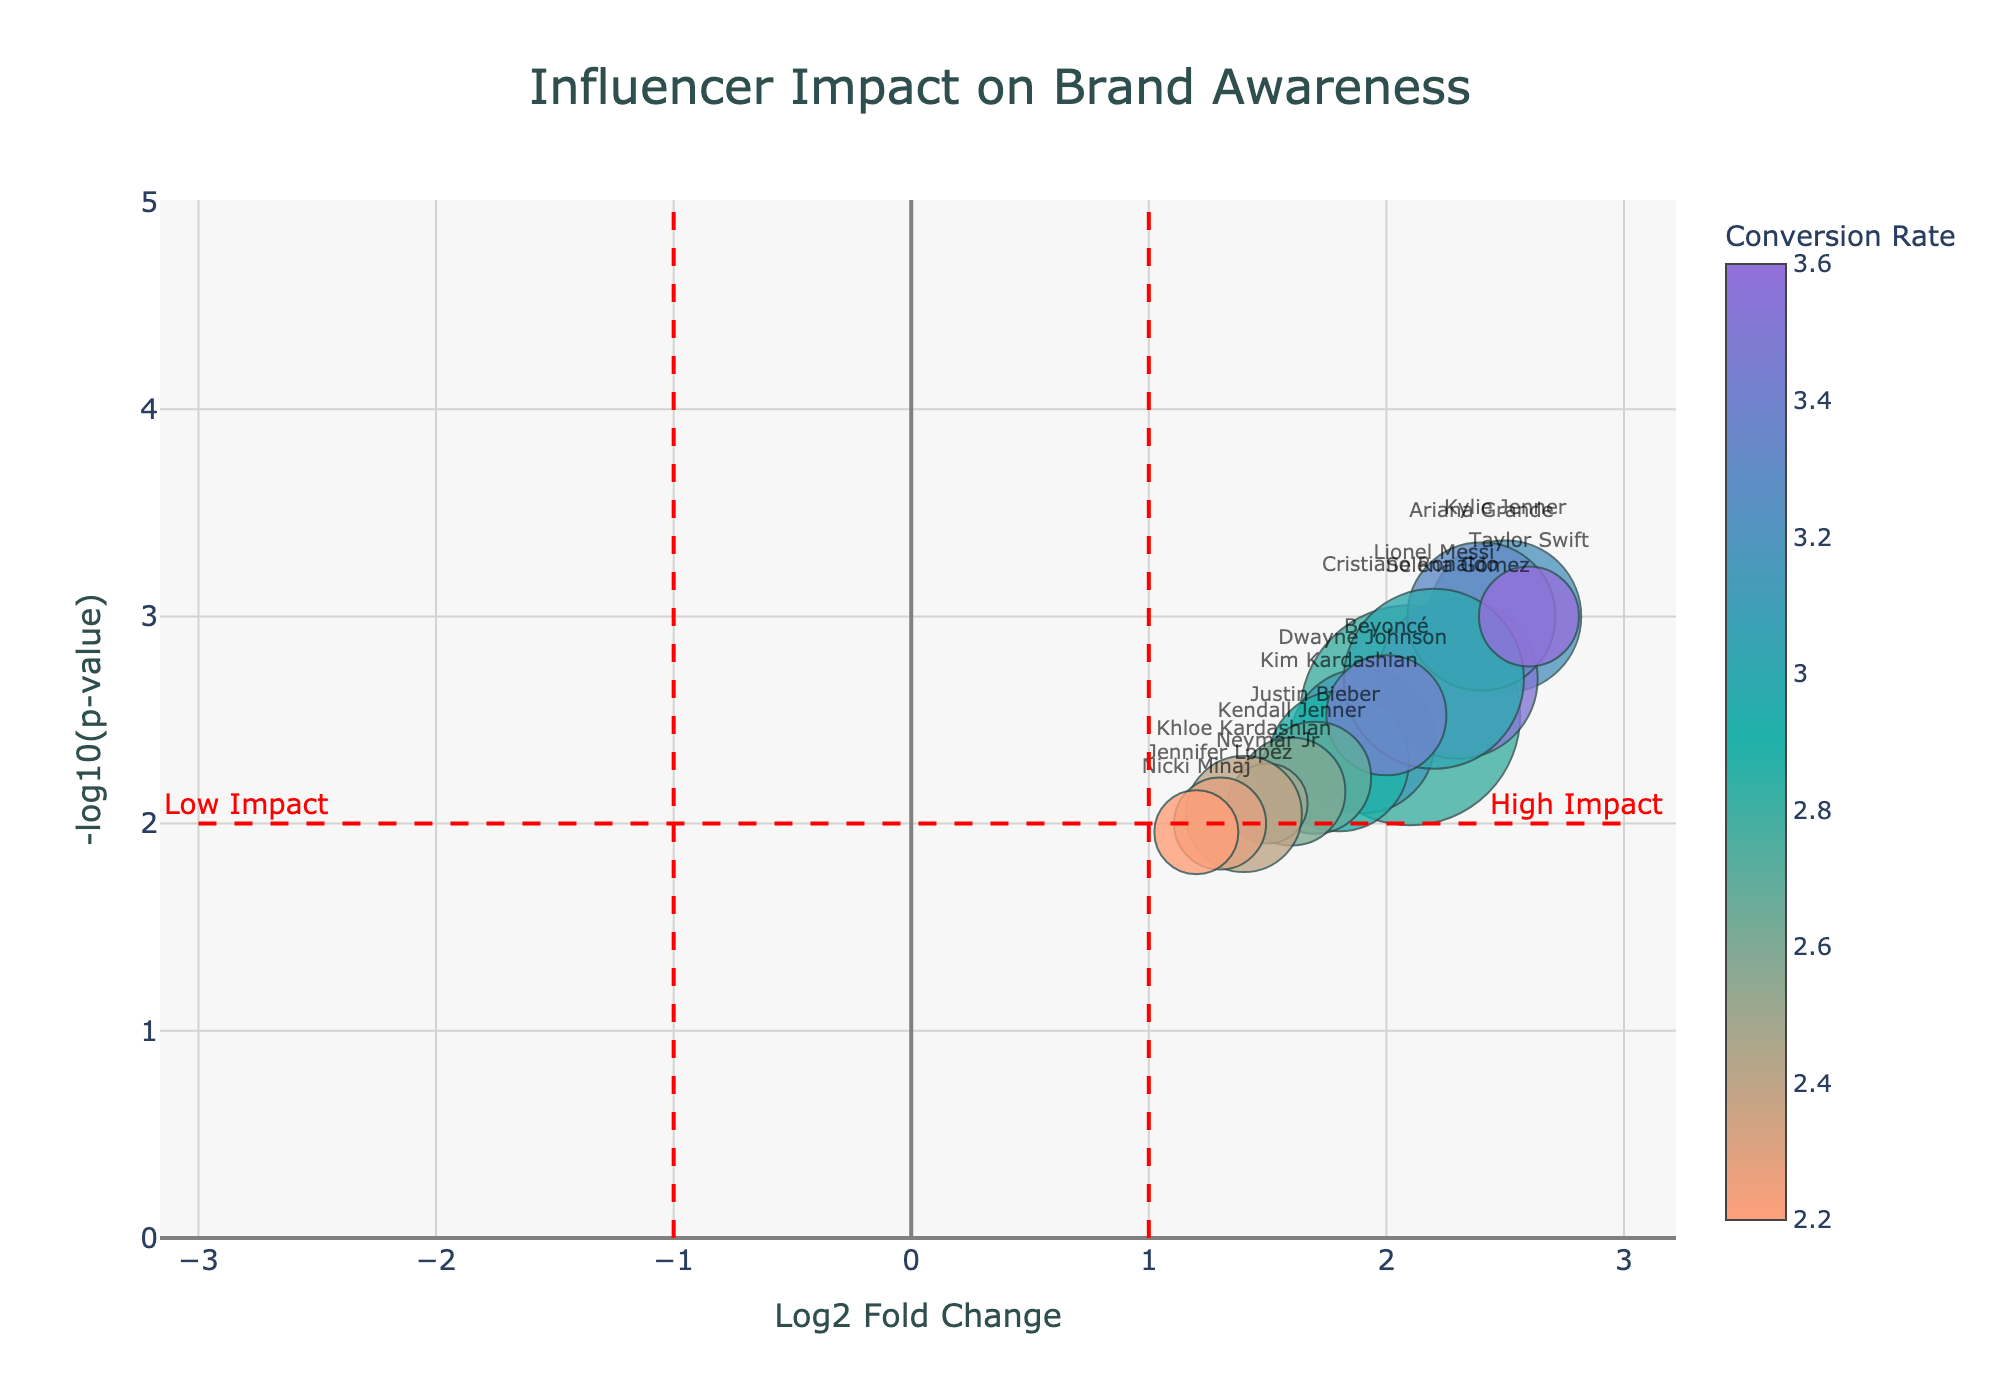What is the title of the plot? The title of the plot is displayed at the center-top of the figure and reads "Influencer Impact on Brand Awareness".
Answer: Influencer Impact on Brand Awareness Which influencer has the highest -log10(p-value)? The highest -log10(p-value) can be found by identifying the data point furthest up on the y-axis. This data point corresponds to Ariana Grande, who has a -log10(p-value) of approximately 3.
Answer: Ariana Grande What does the y-axis represent in the plot? The y-axis is labeled "-log10(p-value)" which represents the negative logarithm (base 10) of the p-value of the conversion rates.
Answer: -log10(p-value) How many influencers have a Log2 Fold Change (Log2FC) greater than 2? By observing the plot, we can count the data points whose x-axis (Log2FC) value is greater than 2. These influencers are Kylie Jenner, Selena Gomez, Ariana Grande, and Taylor Swift.
Answer: 4 Which influencer had the highest conversion rate? The color scale in the plot represents the conversion rate. By observing the colors, Taylor Swift’s marker has the darkest shade, representing the highest conversion rate, which is 3.6%.
Answer: Taylor Swift Which influencers are positioned in the "High Impact" region of the plot? The "High Impact" region is labeled on the right side of the vertical red line at x = 1 and above the horizontal red line at y = 2. The influencers in this region are Kylie Jenner, Selena Gomez, Cristiano Ronaldo, Ariana Grande, Lionel Messi, and Taylor Swift.
Answer: Kylie Jenner, Selena Gomez, Cristiano Ronaldo, Ariana Grande, Lionel Messi, Taylor Swift What is the approximate size of Justin Bieber's marker on the plot? The marker size is proportional to the number of followers divided by 5,000,000. Justin Bieber has 280,000,000 followers. Hence, the marker size for Justin Bieber is approximately 280,000,000 / 5,000,000 = 56.
Answer: 56 Which influencer with over 300,000,000 followers had the lowest Log2 Fold Change? By locating the influencers with over 300,000,000 followers, and then finding the one with the smallest Log2FC, we can see that Kim Kardashian (350,000,000 followers) has the lowest Log2FC at approximately 1.8.
Answer: Kim Kardashian What is the conversion rate range of the influencers on the plot? By observing the color bar on the right side of the plot, the conversion rates range from around 2.2% (lightest shade) to 3.6% (darkest shade).
Answer: 2.2% to 3.6% What is shown at the intersection of the red threshold lines? The intersection of the vertical line (x=1) and the horizontal line (y=2) indicates a significant Log2 Fold Change and p-value threshold, showing that influencers above y=2 and right of x=1 are considered to have a significant high impact.
Answer: Significant high impact threshold 